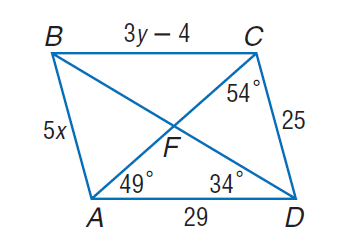Answer the mathemtical geometry problem and directly provide the correct option letter.
Question: Use parallelogram A B C D to find x.
Choices: A: 2 B: 5 C: 25 D: 50 B 